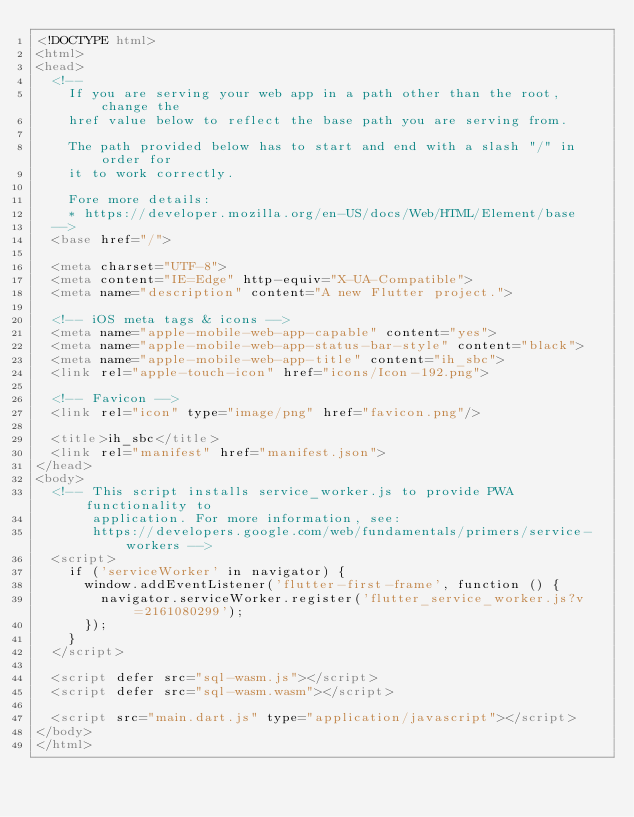<code> <loc_0><loc_0><loc_500><loc_500><_HTML_><!DOCTYPE html>
<html>
<head>
  <!--
    If you are serving your web app in a path other than the root, change the
    href value below to reflect the base path you are serving from.

    The path provided below has to start and end with a slash "/" in order for
    it to work correctly.

    Fore more details:
    * https://developer.mozilla.org/en-US/docs/Web/HTML/Element/base
  -->
  <base href="/">

  <meta charset="UTF-8">
  <meta content="IE=Edge" http-equiv="X-UA-Compatible">
  <meta name="description" content="A new Flutter project.">

  <!-- iOS meta tags & icons -->
  <meta name="apple-mobile-web-app-capable" content="yes">
  <meta name="apple-mobile-web-app-status-bar-style" content="black">
  <meta name="apple-mobile-web-app-title" content="ih_sbc">
  <link rel="apple-touch-icon" href="icons/Icon-192.png">

  <!-- Favicon -->
  <link rel="icon" type="image/png" href="favicon.png"/>

  <title>ih_sbc</title>
  <link rel="manifest" href="manifest.json">
</head>
<body>
  <!-- This script installs service_worker.js to provide PWA functionality to
       application. For more information, see:
       https://developers.google.com/web/fundamentals/primers/service-workers -->
  <script>
    if ('serviceWorker' in navigator) {
      window.addEventListener('flutter-first-frame', function () {
        navigator.serviceWorker.register('flutter_service_worker.js?v=2161080299');
      });
    }
  </script>

  <script defer src="sql-wasm.js"></script>
  <script defer src="sql-wasm.wasm"></script>

  <script src="main.dart.js" type="application/javascript"></script>
</body>
</html>
</code> 